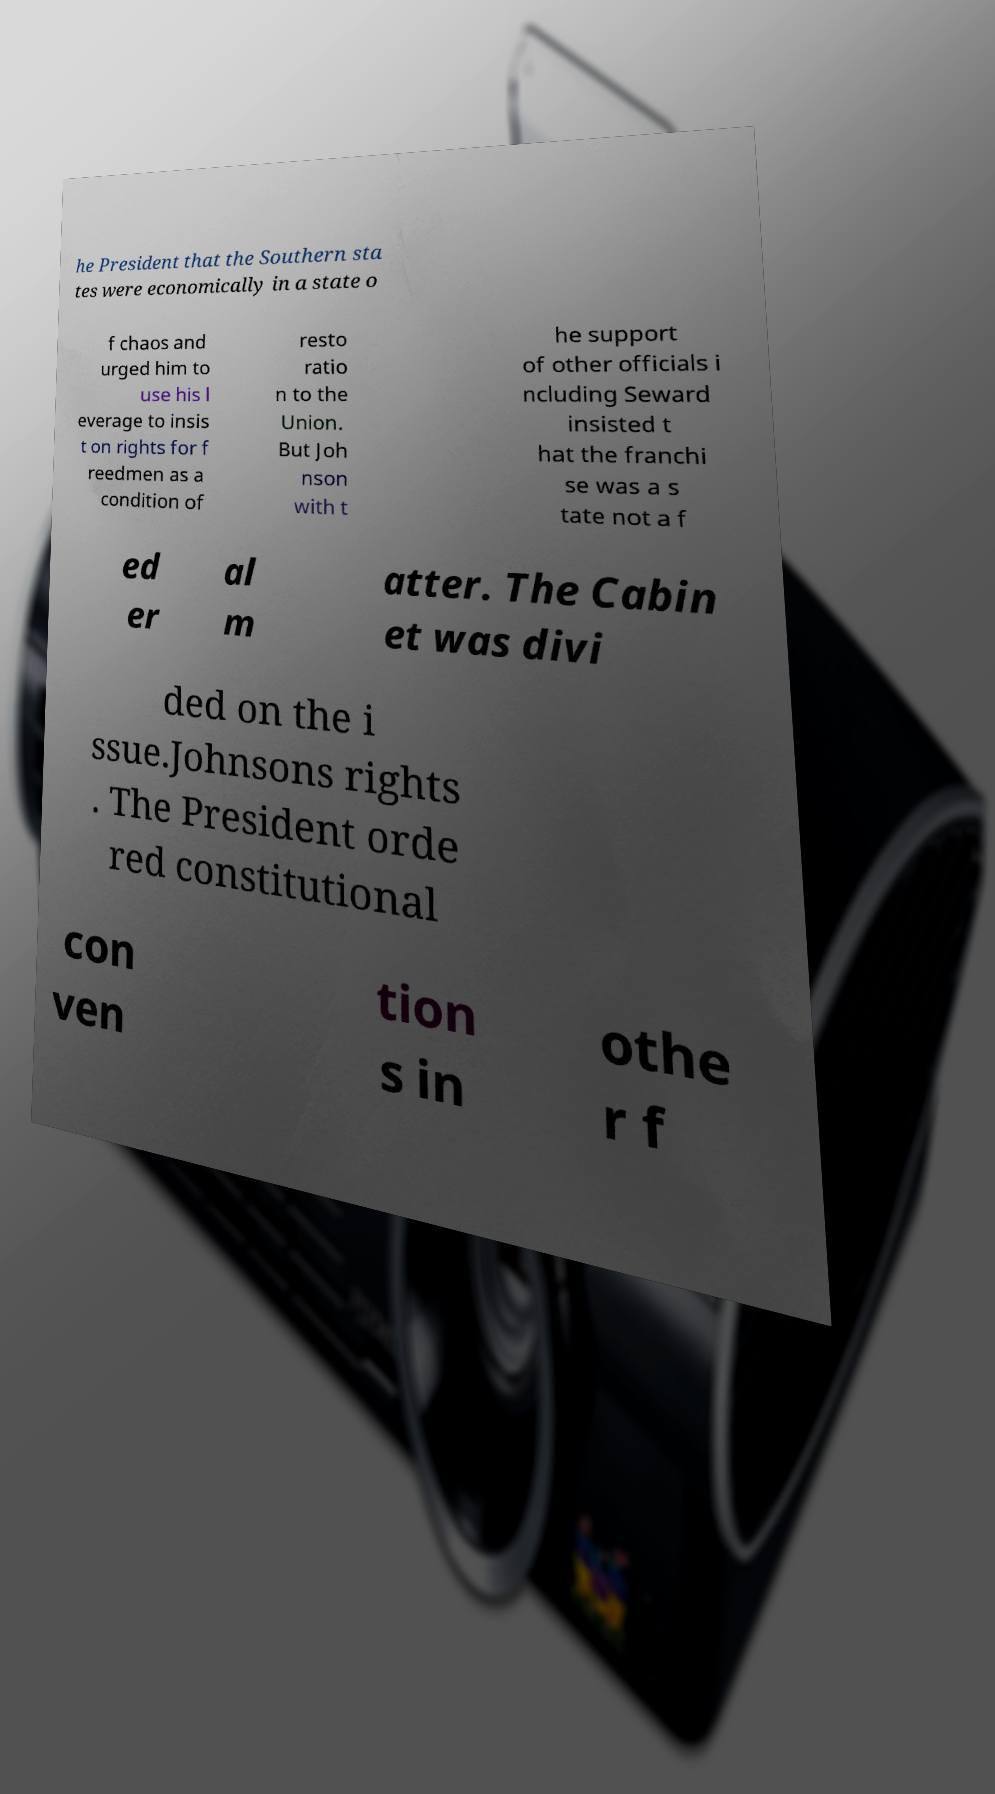I need the written content from this picture converted into text. Can you do that? he President that the Southern sta tes were economically in a state o f chaos and urged him to use his l everage to insis t on rights for f reedmen as a condition of resto ratio n to the Union. But Joh nson with t he support of other officials i ncluding Seward insisted t hat the franchi se was a s tate not a f ed er al m atter. The Cabin et was divi ded on the i ssue.Johnsons rights . The President orde red constitutional con ven tion s in othe r f 